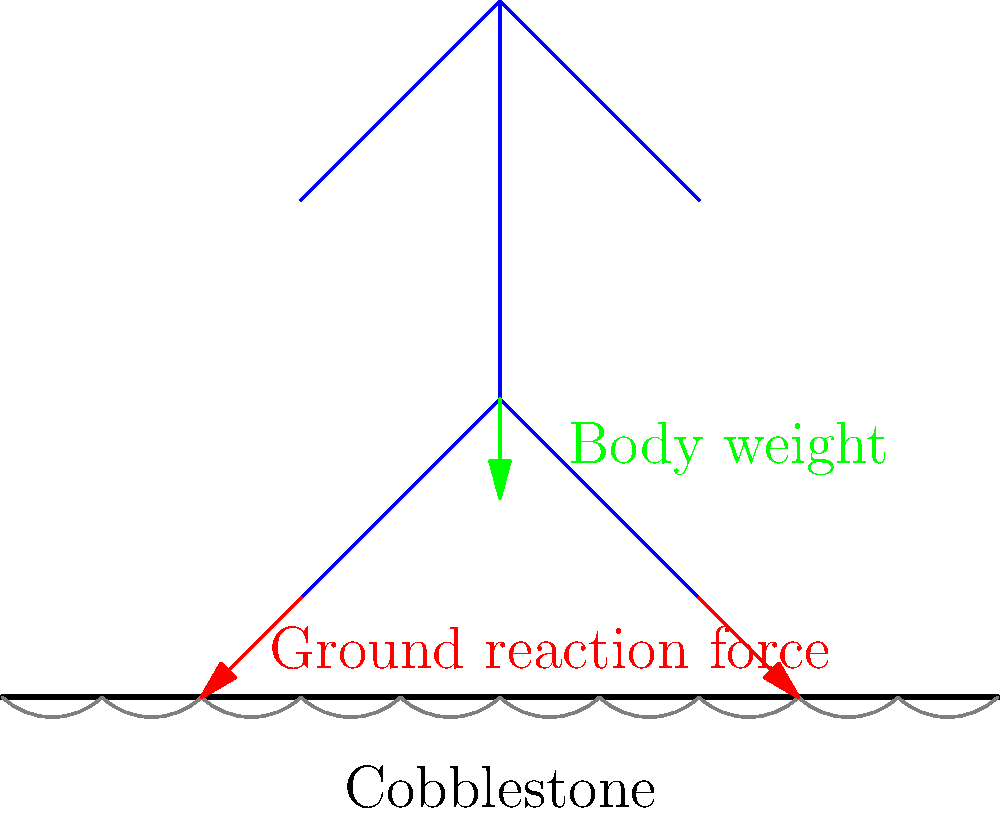As a tourism agent in West Flanders, you often guide visitors through historic towns with cobblestone streets. Consider the biomechanics of walking on such surfaces. In the simplified skeletal diagram, what is the primary force acting on the person's ankle joints when their foot contacts a cobblestone, and how does this differ from walking on a flat surface? To understand the forces acting on a person's ankle joints while walking on cobblestone streets, let's break it down step-by-step:

1. Normal walking on flat surfaces:
   - The ground reaction force (GRF) is distributed evenly across the foot.
   - The ankle joint experiences a gradual increase in force as the foot makes contact with the ground.

2. Walking on cobblestone streets:
   - The uneven surface creates localized pressure points.
   - When the foot contacts a cobblestone:
     a. The GRF is concentrated on a smaller area.
     b. This concentration leads to a more sudden and intense force on the ankle joint.

3. Primary force acting on the ankle:
   - The primary force is still the ground reaction force (GRF).
   - However, on cobblestones, the GRF is:
     a. More variable in magnitude and direction.
     b. Often higher in peak force due to the uneven surface.

4. Difference from flat surfaces:
   - On flat surfaces: $F_{GRF} = m \cdot g$ (where m is mass and g is gravity)
   - On cobblestones: $F_{GRF} > m \cdot g$ (due to impact and instability)

5. Additional considerations:
   - Ankle joints experience increased rotational forces (torque) due to the uneven surface.
   - This can be represented as: $\tau = r \times F_{GRF}$ 
     where $\tau$ is torque, $r$ is the moment arm, and $F_{GRF}$ is the ground reaction force.

6. Impact on tourism:
   - Visitors may experience increased fatigue and potential discomfort.
   - As a tourism agent, it's important to advise on appropriate footwear and potential rest stops.

In summary, while the primary force remains the ground reaction force, its application on cobblestone streets is more intense, variable, and localized, leading to increased stress on the ankle joints compared to flat surfaces.
Answer: Concentrated, variable ground reaction force (GRF), higher than on flat surfaces 